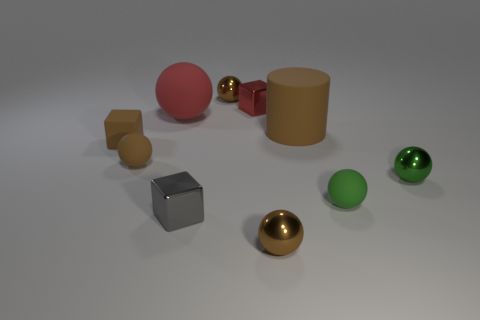There is a object that is the same color as the large matte ball; what is its material?
Ensure brevity in your answer.  Metal. How many objects are either brown matte balls or gray shiny blocks that are in front of the red metallic block?
Make the answer very short. 2. Is the number of small green metal spheres less than the number of tiny yellow metal things?
Your answer should be very brief. No. Is the number of large brown cylinders greater than the number of large green shiny balls?
Keep it short and to the point. Yes. How many other objects are there of the same material as the big red thing?
Keep it short and to the point. 4. How many small green spheres are in front of the tiny metallic sphere on the right side of the small matte ball that is on the right side of the small red metallic object?
Offer a very short reply. 1. How many metallic objects are either tiny blocks or tiny blue cylinders?
Offer a terse response. 2. What is the size of the brown rubber thing that is on the right side of the rubber thing behind the rubber cylinder?
Your answer should be compact. Large. Does the small rubber sphere on the right side of the large brown rubber object have the same color as the shiny sphere to the right of the small green matte thing?
Provide a short and direct response. Yes. The ball that is both in front of the red rubber thing and to the left of the tiny gray thing is what color?
Provide a succinct answer. Brown. 